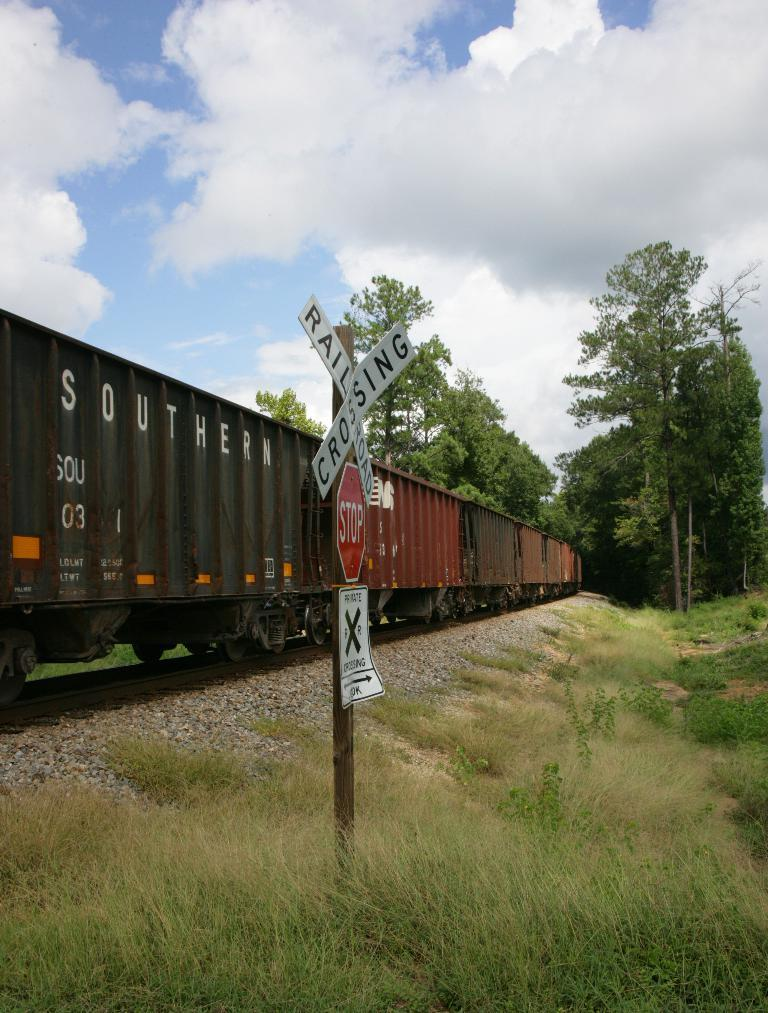What can be seen on the track in the image? There are train wagons on the track in the image. What is present in the background of the image? There is a pole with a sign board and a group of trees in the background of the image. How would you describe the sky in the image? The sky is cloudy in the background of the image. What type of whip is being used to make bread in the image? There is no whip or bread present in the image; it features train wagons on a track with a pole, trees, and a cloudy sky in the background. 